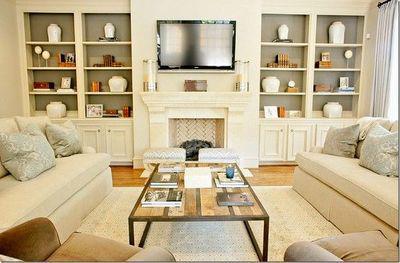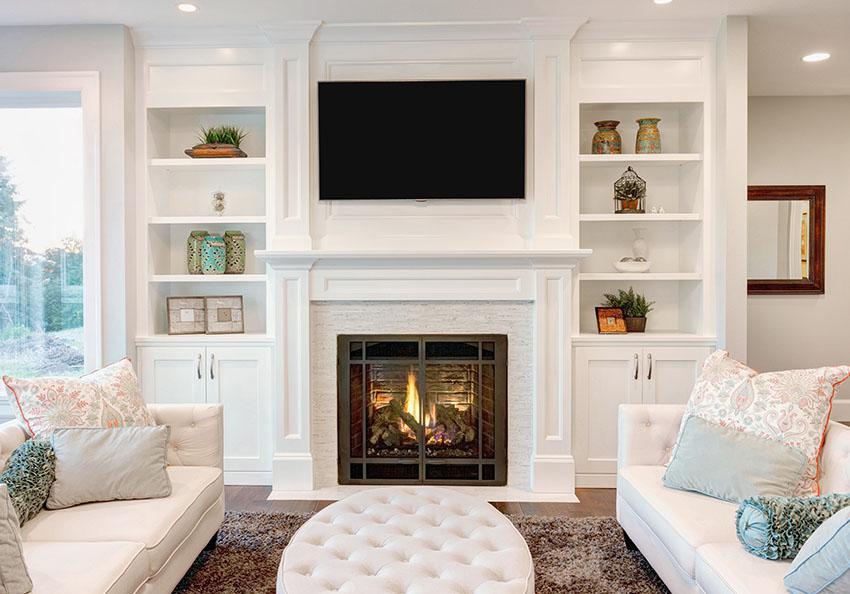The first image is the image on the left, the second image is the image on the right. Evaluate the accuracy of this statement regarding the images: "There is a TV above a fireplace in the right image.". Is it true? Answer yes or no. Yes. The first image is the image on the left, the second image is the image on the right. Examine the images to the left and right. Is the description "In at least one image, a fireplace with an overhead television is flanked by shelves." accurate? Answer yes or no. Yes. 